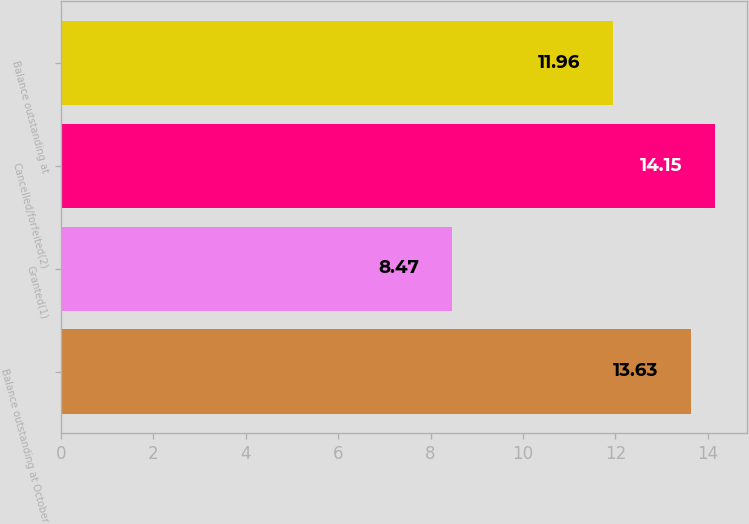<chart> <loc_0><loc_0><loc_500><loc_500><bar_chart><fcel>Balance outstanding at October<fcel>Granted(1)<fcel>Cancelled/forfeited(2)<fcel>Balance outstanding at<nl><fcel>13.63<fcel>8.47<fcel>14.15<fcel>11.96<nl></chart> 